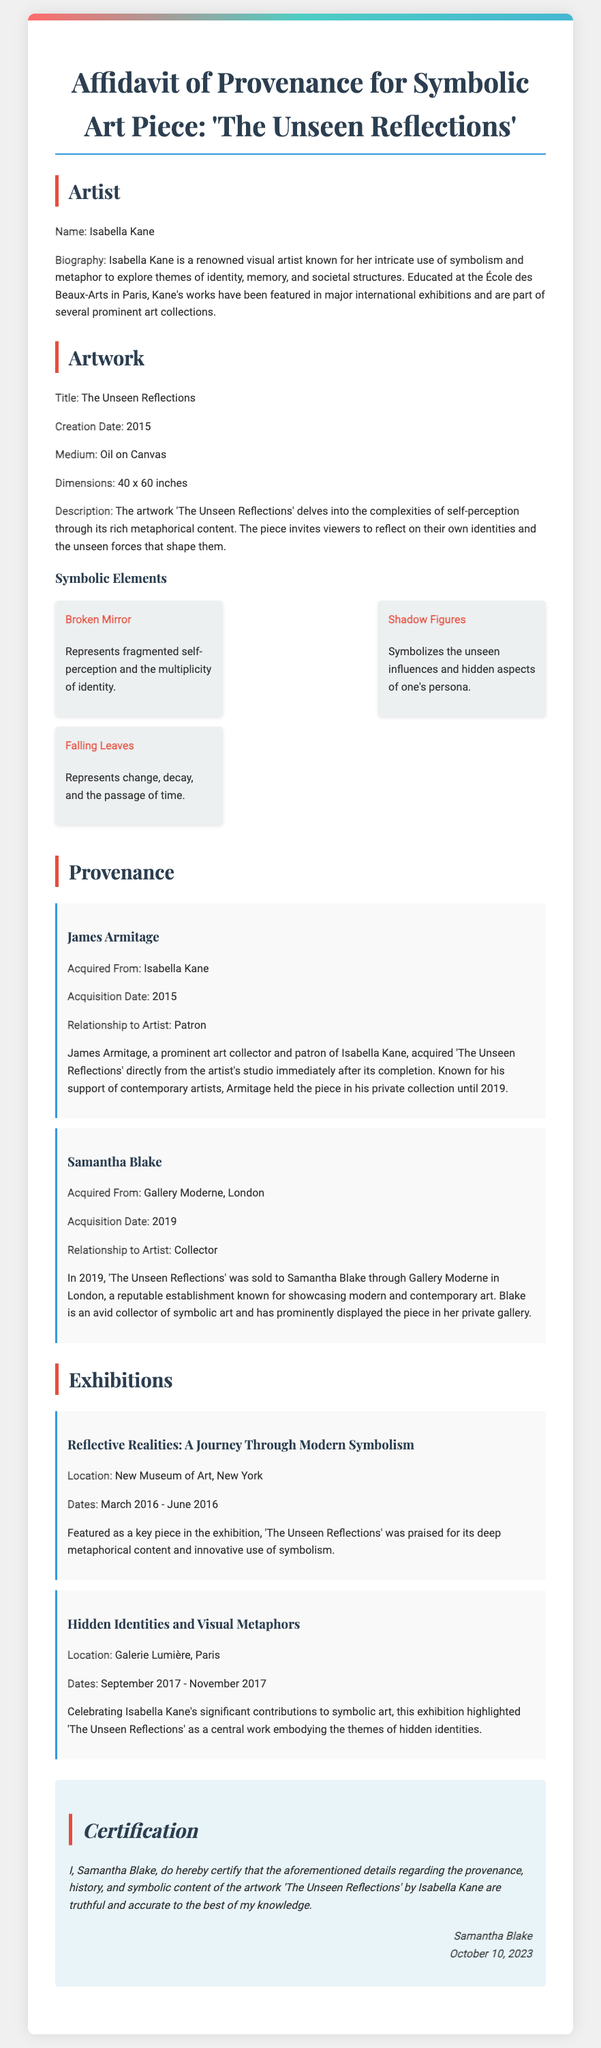What is the title of the artwork? The title of the artwork is stated in the artwork section of the document.
Answer: The Unseen Reflections Who is the artist of the artwork? The artist's name is provided in the artist information section of the document.
Answer: Isabella Kane What year was 'The Unseen Reflections' created? The creation date is listed in the artwork section of the document.
Answer: 2015 Which medium was used for the artwork? The medium is specified right after the creation date in the artwork section of the document.
Answer: Oil on Canvas Who acquired the artwork in 2019? The name of the individual who purchased the artwork in 2019 is mentioned in the provenance section.
Answer: Samantha Blake What does the broken mirror symbolize in the artwork? The meaning of the broken mirror is explained within the symbolic elements of the artwork.
Answer: Fragmented self-perception What was the location of the exhibition 'Reflective Realities'? The location for this specific exhibition is detailed in the exhibitions section of the document.
Answer: New Museum of Art, New York In what capacity did James Armitage acquire the artwork? The relationship to the artist concerning James Armitage is explained in the provenance section.
Answer: Patron What is the date of certification by Samantha Blake? The certification date is found at the end of the document in the certification section.
Answer: October 10, 2023 